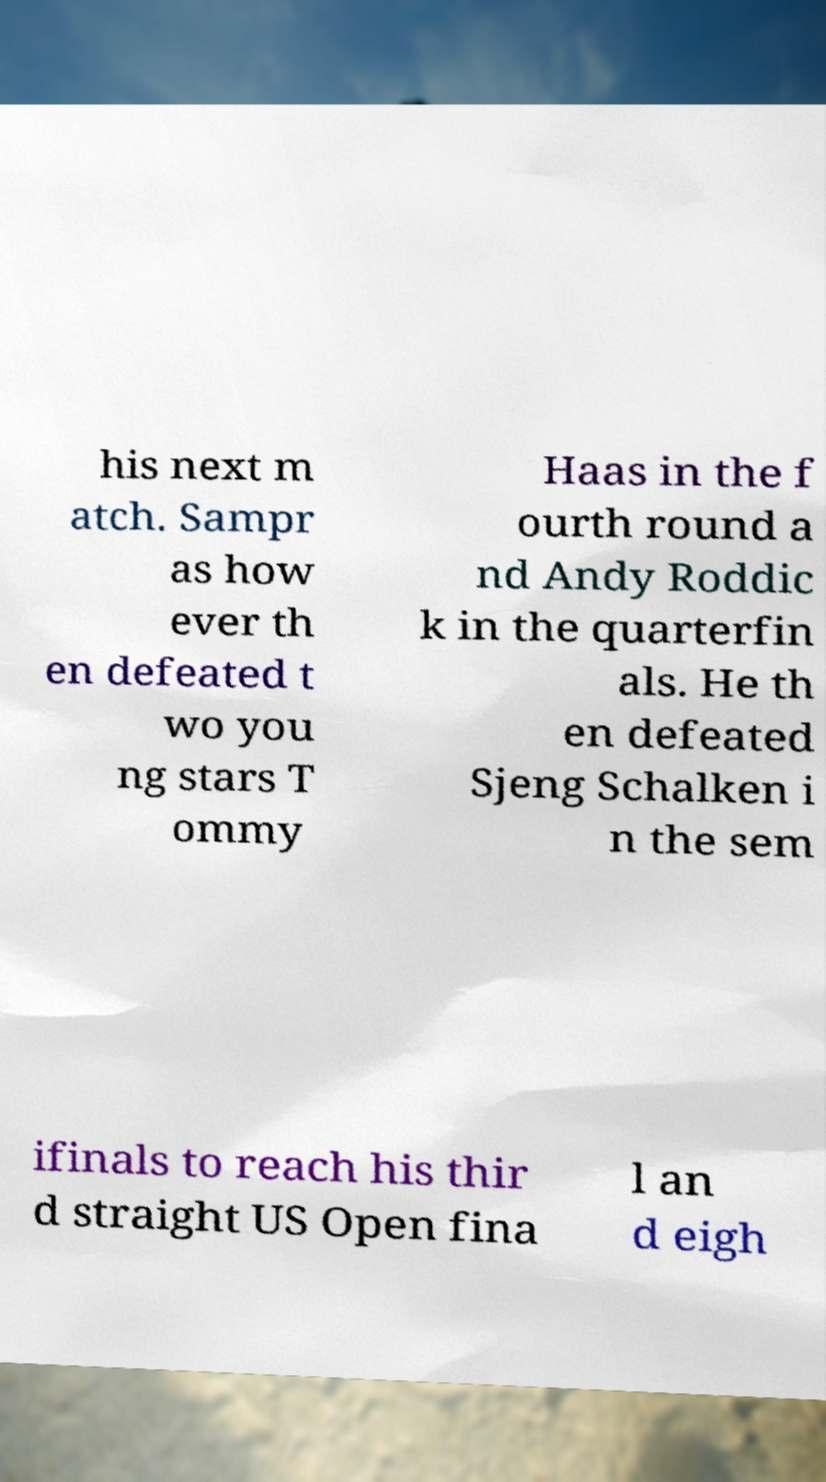Please read and relay the text visible in this image. What does it say? his next m atch. Sampr as how ever th en defeated t wo you ng stars T ommy Haas in the f ourth round a nd Andy Roddic k in the quarterfin als. He th en defeated Sjeng Schalken i n the sem ifinals to reach his thir d straight US Open fina l an d eigh 